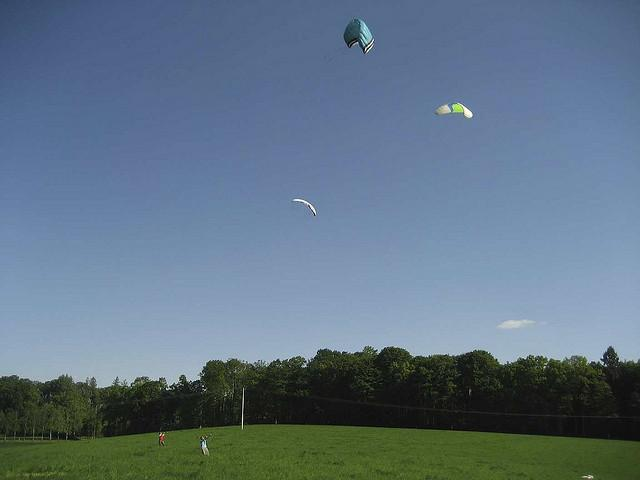The flying objects are made of what material? nylon 